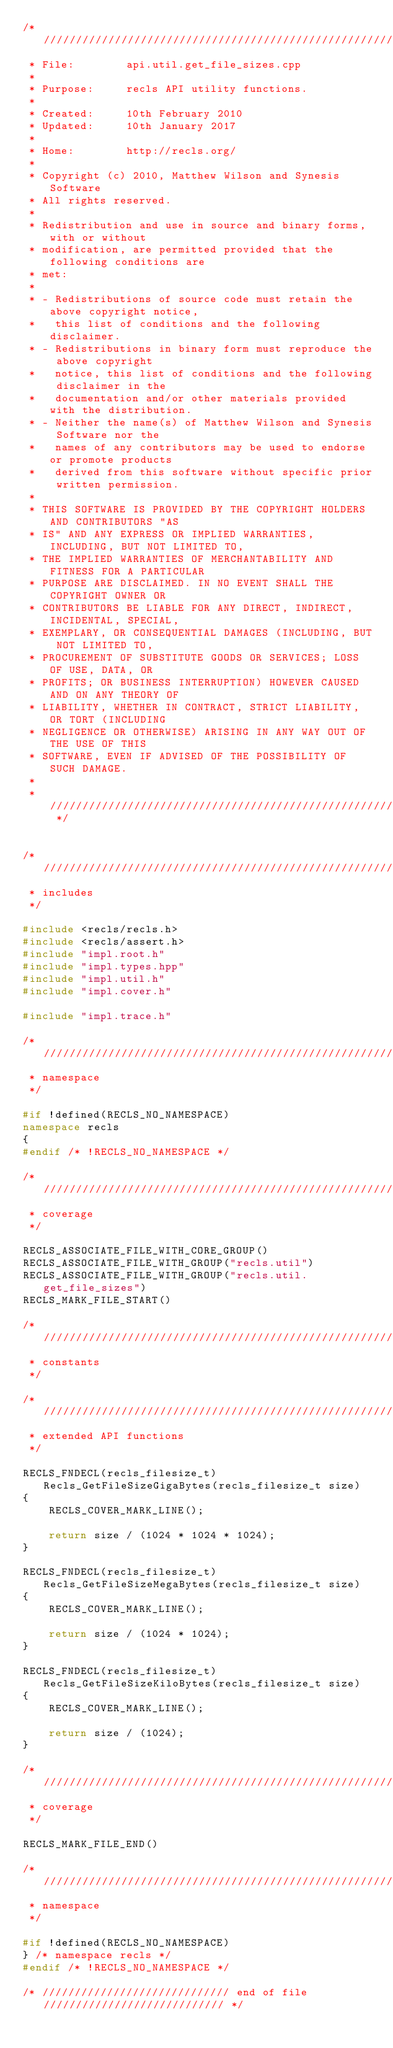Convert code to text. <code><loc_0><loc_0><loc_500><loc_500><_C++_>/* /////////////////////////////////////////////////////////////////////////
 * File:        api.util.get_file_sizes.cpp
 *
 * Purpose:     recls API utility functions.
 *
 * Created:     10th February 2010
 * Updated:     10th January 2017
 *
 * Home:        http://recls.org/
 *
 * Copyright (c) 2010, Matthew Wilson and Synesis Software
 * All rights reserved.
 *
 * Redistribution and use in source and binary forms, with or without 
 * modification, are permitted provided that the following conditions are
 * met:
 *
 * - Redistributions of source code must retain the above copyright notice,
 *   this list of conditions and the following disclaimer.
 * - Redistributions in binary form must reproduce the above copyright
 *   notice, this list of conditions and the following disclaimer in the
 *   documentation and/or other materials provided with the distribution.
 * - Neither the name(s) of Matthew Wilson and Synesis Software nor the
 *   names of any contributors may be used to endorse or promote products
 *   derived from this software without specific prior written permission.
 *
 * THIS SOFTWARE IS PROVIDED BY THE COPYRIGHT HOLDERS AND CONTRIBUTORS "AS
 * IS" AND ANY EXPRESS OR IMPLIED WARRANTIES, INCLUDING, BUT NOT LIMITED TO,
 * THE IMPLIED WARRANTIES OF MERCHANTABILITY AND FITNESS FOR A PARTICULAR
 * PURPOSE ARE DISCLAIMED. IN NO EVENT SHALL THE COPYRIGHT OWNER OR
 * CONTRIBUTORS BE LIABLE FOR ANY DIRECT, INDIRECT, INCIDENTAL, SPECIAL,
 * EXEMPLARY, OR CONSEQUENTIAL DAMAGES (INCLUDING, BUT NOT LIMITED TO,
 * PROCUREMENT OF SUBSTITUTE GOODS OR SERVICES; LOSS OF USE, DATA, OR
 * PROFITS; OR BUSINESS INTERRUPTION) HOWEVER CAUSED AND ON ANY THEORY OF
 * LIABILITY, WHETHER IN CONTRACT, STRICT LIABILITY, OR TORT (INCLUDING
 * NEGLIGENCE OR OTHERWISE) ARISING IN ANY WAY OUT OF THE USE OF THIS
 * SOFTWARE, EVEN IF ADVISED OF THE POSSIBILITY OF SUCH DAMAGE.
 *
 * ////////////////////////////////////////////////////////////////////// */


/* /////////////////////////////////////////////////////////////////////////
 * includes
 */

#include <recls/recls.h>
#include <recls/assert.h>
#include "impl.root.h"
#include "impl.types.hpp"
#include "impl.util.h"
#include "impl.cover.h"

#include "impl.trace.h"

/* /////////////////////////////////////////////////////////////////////////
 * namespace
 */

#if !defined(RECLS_NO_NAMESPACE)
namespace recls
{
#endif /* !RECLS_NO_NAMESPACE */

/* /////////////////////////////////////////////////////////////////////////
 * coverage
 */

RECLS_ASSOCIATE_FILE_WITH_CORE_GROUP()
RECLS_ASSOCIATE_FILE_WITH_GROUP("recls.util")
RECLS_ASSOCIATE_FILE_WITH_GROUP("recls.util.get_file_sizes")
RECLS_MARK_FILE_START()

/* /////////////////////////////////////////////////////////////////////////
 * constants
 */

/* /////////////////////////////////////////////////////////////////////////
 * extended API functions
 */

RECLS_FNDECL(recls_filesize_t) Recls_GetFileSizeGigaBytes(recls_filesize_t size)
{
    RECLS_COVER_MARK_LINE();

    return size / (1024 * 1024 * 1024);
}

RECLS_FNDECL(recls_filesize_t) Recls_GetFileSizeMegaBytes(recls_filesize_t size)
{
    RECLS_COVER_MARK_LINE();

    return size / (1024 * 1024);
}

RECLS_FNDECL(recls_filesize_t) Recls_GetFileSizeKiloBytes(recls_filesize_t size)
{
    RECLS_COVER_MARK_LINE();

    return size / (1024);
}

/* /////////////////////////////////////////////////////////////////////////
 * coverage
 */

RECLS_MARK_FILE_END()

/* /////////////////////////////////////////////////////////////////////////
 * namespace
 */

#if !defined(RECLS_NO_NAMESPACE)
} /* namespace recls */
#endif /* !RECLS_NO_NAMESPACE */

/* ///////////////////////////// end of file //////////////////////////// */
</code> 